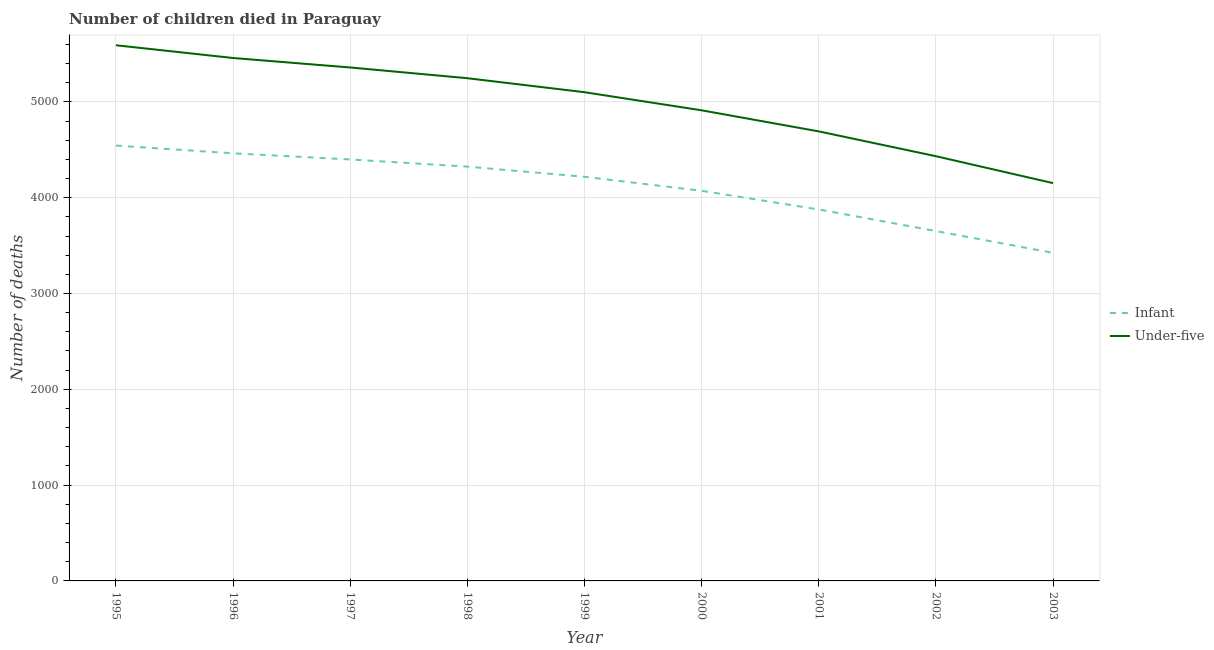How many different coloured lines are there?
Offer a terse response. 2. Does the line corresponding to number of infant deaths intersect with the line corresponding to number of under-five deaths?
Give a very brief answer. No. Is the number of lines equal to the number of legend labels?
Your answer should be compact. Yes. What is the number of infant deaths in 1996?
Provide a short and direct response. 4463. Across all years, what is the maximum number of infant deaths?
Ensure brevity in your answer.  4544. Across all years, what is the minimum number of under-five deaths?
Provide a succinct answer. 4152. In which year was the number of infant deaths minimum?
Provide a succinct answer. 2003. What is the total number of under-five deaths in the graph?
Ensure brevity in your answer.  4.49e+04. What is the difference between the number of under-five deaths in 2000 and that in 2002?
Provide a short and direct response. 479. What is the difference between the number of under-five deaths in 1998 and the number of infant deaths in 1996?
Your response must be concise. 784. What is the average number of infant deaths per year?
Ensure brevity in your answer.  4108.11. In the year 1997, what is the difference between the number of infant deaths and number of under-five deaths?
Offer a terse response. -960. What is the ratio of the number of under-five deaths in 2001 to that in 2003?
Give a very brief answer. 1.13. What is the difference between the highest and the second highest number of infant deaths?
Give a very brief answer. 81. What is the difference between the highest and the lowest number of infant deaths?
Provide a succinct answer. 1120. In how many years, is the number of infant deaths greater than the average number of infant deaths taken over all years?
Your answer should be very brief. 5. Does the number of under-five deaths monotonically increase over the years?
Your answer should be compact. No. How many lines are there?
Provide a succinct answer. 2. How many years are there in the graph?
Offer a terse response. 9. What is the difference between two consecutive major ticks on the Y-axis?
Your answer should be compact. 1000. Does the graph contain any zero values?
Your answer should be compact. No. What is the title of the graph?
Provide a succinct answer. Number of children died in Paraguay. What is the label or title of the Y-axis?
Offer a very short reply. Number of deaths. What is the Number of deaths of Infant in 1995?
Provide a short and direct response. 4544. What is the Number of deaths in Under-five in 1995?
Provide a short and direct response. 5591. What is the Number of deaths in Infant in 1996?
Provide a short and direct response. 4463. What is the Number of deaths of Under-five in 1996?
Provide a succinct answer. 5458. What is the Number of deaths in Infant in 1997?
Provide a succinct answer. 4399. What is the Number of deaths of Under-five in 1997?
Make the answer very short. 5359. What is the Number of deaths of Infant in 1998?
Make the answer very short. 4324. What is the Number of deaths in Under-five in 1998?
Provide a short and direct response. 5247. What is the Number of deaths of Infant in 1999?
Offer a terse response. 4218. What is the Number of deaths in Under-five in 1999?
Your answer should be very brief. 5101. What is the Number of deaths in Infant in 2000?
Make the answer very short. 4072. What is the Number of deaths in Under-five in 2000?
Make the answer very short. 4912. What is the Number of deaths of Infant in 2001?
Offer a very short reply. 3877. What is the Number of deaths of Under-five in 2001?
Your answer should be very brief. 4692. What is the Number of deaths of Infant in 2002?
Make the answer very short. 3652. What is the Number of deaths in Under-five in 2002?
Your answer should be very brief. 4433. What is the Number of deaths of Infant in 2003?
Your answer should be very brief. 3424. What is the Number of deaths in Under-five in 2003?
Your response must be concise. 4152. Across all years, what is the maximum Number of deaths in Infant?
Offer a terse response. 4544. Across all years, what is the maximum Number of deaths in Under-five?
Keep it short and to the point. 5591. Across all years, what is the minimum Number of deaths in Infant?
Make the answer very short. 3424. Across all years, what is the minimum Number of deaths of Under-five?
Ensure brevity in your answer.  4152. What is the total Number of deaths in Infant in the graph?
Provide a short and direct response. 3.70e+04. What is the total Number of deaths of Under-five in the graph?
Give a very brief answer. 4.49e+04. What is the difference between the Number of deaths in Under-five in 1995 and that in 1996?
Provide a short and direct response. 133. What is the difference between the Number of deaths in Infant in 1995 and that in 1997?
Provide a succinct answer. 145. What is the difference between the Number of deaths in Under-five in 1995 and that in 1997?
Make the answer very short. 232. What is the difference between the Number of deaths in Infant in 1995 and that in 1998?
Offer a terse response. 220. What is the difference between the Number of deaths in Under-five in 1995 and that in 1998?
Offer a terse response. 344. What is the difference between the Number of deaths of Infant in 1995 and that in 1999?
Your response must be concise. 326. What is the difference between the Number of deaths of Under-five in 1995 and that in 1999?
Ensure brevity in your answer.  490. What is the difference between the Number of deaths of Infant in 1995 and that in 2000?
Offer a terse response. 472. What is the difference between the Number of deaths in Under-five in 1995 and that in 2000?
Make the answer very short. 679. What is the difference between the Number of deaths of Infant in 1995 and that in 2001?
Your answer should be compact. 667. What is the difference between the Number of deaths of Under-five in 1995 and that in 2001?
Offer a terse response. 899. What is the difference between the Number of deaths in Infant in 1995 and that in 2002?
Ensure brevity in your answer.  892. What is the difference between the Number of deaths of Under-five in 1995 and that in 2002?
Your response must be concise. 1158. What is the difference between the Number of deaths of Infant in 1995 and that in 2003?
Ensure brevity in your answer.  1120. What is the difference between the Number of deaths in Under-five in 1995 and that in 2003?
Your answer should be compact. 1439. What is the difference between the Number of deaths in Under-five in 1996 and that in 1997?
Make the answer very short. 99. What is the difference between the Number of deaths of Infant in 1996 and that in 1998?
Ensure brevity in your answer.  139. What is the difference between the Number of deaths in Under-five in 1996 and that in 1998?
Keep it short and to the point. 211. What is the difference between the Number of deaths of Infant in 1996 and that in 1999?
Ensure brevity in your answer.  245. What is the difference between the Number of deaths of Under-five in 1996 and that in 1999?
Offer a terse response. 357. What is the difference between the Number of deaths of Infant in 1996 and that in 2000?
Offer a terse response. 391. What is the difference between the Number of deaths in Under-five in 1996 and that in 2000?
Give a very brief answer. 546. What is the difference between the Number of deaths of Infant in 1996 and that in 2001?
Keep it short and to the point. 586. What is the difference between the Number of deaths of Under-five in 1996 and that in 2001?
Provide a succinct answer. 766. What is the difference between the Number of deaths in Infant in 1996 and that in 2002?
Offer a very short reply. 811. What is the difference between the Number of deaths in Under-five in 1996 and that in 2002?
Make the answer very short. 1025. What is the difference between the Number of deaths in Infant in 1996 and that in 2003?
Keep it short and to the point. 1039. What is the difference between the Number of deaths of Under-five in 1996 and that in 2003?
Offer a very short reply. 1306. What is the difference between the Number of deaths of Infant in 1997 and that in 1998?
Keep it short and to the point. 75. What is the difference between the Number of deaths in Under-five in 1997 and that in 1998?
Provide a short and direct response. 112. What is the difference between the Number of deaths of Infant in 1997 and that in 1999?
Your answer should be very brief. 181. What is the difference between the Number of deaths of Under-five in 1997 and that in 1999?
Your answer should be compact. 258. What is the difference between the Number of deaths of Infant in 1997 and that in 2000?
Offer a very short reply. 327. What is the difference between the Number of deaths of Under-five in 1997 and that in 2000?
Your answer should be very brief. 447. What is the difference between the Number of deaths of Infant in 1997 and that in 2001?
Your answer should be very brief. 522. What is the difference between the Number of deaths of Under-five in 1997 and that in 2001?
Keep it short and to the point. 667. What is the difference between the Number of deaths of Infant in 1997 and that in 2002?
Make the answer very short. 747. What is the difference between the Number of deaths in Under-five in 1997 and that in 2002?
Your response must be concise. 926. What is the difference between the Number of deaths of Infant in 1997 and that in 2003?
Provide a short and direct response. 975. What is the difference between the Number of deaths in Under-five in 1997 and that in 2003?
Your answer should be compact. 1207. What is the difference between the Number of deaths of Infant in 1998 and that in 1999?
Ensure brevity in your answer.  106. What is the difference between the Number of deaths in Under-five in 1998 and that in 1999?
Keep it short and to the point. 146. What is the difference between the Number of deaths in Infant in 1998 and that in 2000?
Provide a succinct answer. 252. What is the difference between the Number of deaths in Under-five in 1998 and that in 2000?
Keep it short and to the point. 335. What is the difference between the Number of deaths of Infant in 1998 and that in 2001?
Ensure brevity in your answer.  447. What is the difference between the Number of deaths in Under-five in 1998 and that in 2001?
Your answer should be compact. 555. What is the difference between the Number of deaths in Infant in 1998 and that in 2002?
Provide a short and direct response. 672. What is the difference between the Number of deaths in Under-five in 1998 and that in 2002?
Offer a terse response. 814. What is the difference between the Number of deaths of Infant in 1998 and that in 2003?
Your response must be concise. 900. What is the difference between the Number of deaths of Under-five in 1998 and that in 2003?
Provide a short and direct response. 1095. What is the difference between the Number of deaths in Infant in 1999 and that in 2000?
Your answer should be very brief. 146. What is the difference between the Number of deaths of Under-five in 1999 and that in 2000?
Your answer should be compact. 189. What is the difference between the Number of deaths in Infant in 1999 and that in 2001?
Your answer should be compact. 341. What is the difference between the Number of deaths of Under-five in 1999 and that in 2001?
Provide a short and direct response. 409. What is the difference between the Number of deaths in Infant in 1999 and that in 2002?
Your answer should be compact. 566. What is the difference between the Number of deaths of Under-five in 1999 and that in 2002?
Ensure brevity in your answer.  668. What is the difference between the Number of deaths of Infant in 1999 and that in 2003?
Make the answer very short. 794. What is the difference between the Number of deaths of Under-five in 1999 and that in 2003?
Your response must be concise. 949. What is the difference between the Number of deaths in Infant in 2000 and that in 2001?
Give a very brief answer. 195. What is the difference between the Number of deaths of Under-five in 2000 and that in 2001?
Provide a short and direct response. 220. What is the difference between the Number of deaths in Infant in 2000 and that in 2002?
Offer a terse response. 420. What is the difference between the Number of deaths in Under-five in 2000 and that in 2002?
Make the answer very short. 479. What is the difference between the Number of deaths in Infant in 2000 and that in 2003?
Offer a very short reply. 648. What is the difference between the Number of deaths in Under-five in 2000 and that in 2003?
Your answer should be very brief. 760. What is the difference between the Number of deaths of Infant in 2001 and that in 2002?
Provide a short and direct response. 225. What is the difference between the Number of deaths in Under-five in 2001 and that in 2002?
Provide a succinct answer. 259. What is the difference between the Number of deaths in Infant in 2001 and that in 2003?
Offer a terse response. 453. What is the difference between the Number of deaths in Under-five in 2001 and that in 2003?
Provide a succinct answer. 540. What is the difference between the Number of deaths of Infant in 2002 and that in 2003?
Provide a short and direct response. 228. What is the difference between the Number of deaths of Under-five in 2002 and that in 2003?
Give a very brief answer. 281. What is the difference between the Number of deaths of Infant in 1995 and the Number of deaths of Under-five in 1996?
Keep it short and to the point. -914. What is the difference between the Number of deaths of Infant in 1995 and the Number of deaths of Under-five in 1997?
Make the answer very short. -815. What is the difference between the Number of deaths of Infant in 1995 and the Number of deaths of Under-five in 1998?
Provide a succinct answer. -703. What is the difference between the Number of deaths of Infant in 1995 and the Number of deaths of Under-five in 1999?
Offer a terse response. -557. What is the difference between the Number of deaths of Infant in 1995 and the Number of deaths of Under-five in 2000?
Your answer should be compact. -368. What is the difference between the Number of deaths of Infant in 1995 and the Number of deaths of Under-five in 2001?
Give a very brief answer. -148. What is the difference between the Number of deaths of Infant in 1995 and the Number of deaths of Under-five in 2002?
Provide a short and direct response. 111. What is the difference between the Number of deaths of Infant in 1995 and the Number of deaths of Under-five in 2003?
Ensure brevity in your answer.  392. What is the difference between the Number of deaths of Infant in 1996 and the Number of deaths of Under-five in 1997?
Your response must be concise. -896. What is the difference between the Number of deaths of Infant in 1996 and the Number of deaths of Under-five in 1998?
Give a very brief answer. -784. What is the difference between the Number of deaths of Infant in 1996 and the Number of deaths of Under-five in 1999?
Offer a very short reply. -638. What is the difference between the Number of deaths in Infant in 1996 and the Number of deaths in Under-five in 2000?
Provide a short and direct response. -449. What is the difference between the Number of deaths of Infant in 1996 and the Number of deaths of Under-five in 2001?
Provide a short and direct response. -229. What is the difference between the Number of deaths in Infant in 1996 and the Number of deaths in Under-five in 2003?
Provide a succinct answer. 311. What is the difference between the Number of deaths in Infant in 1997 and the Number of deaths in Under-five in 1998?
Your answer should be very brief. -848. What is the difference between the Number of deaths in Infant in 1997 and the Number of deaths in Under-five in 1999?
Ensure brevity in your answer.  -702. What is the difference between the Number of deaths in Infant in 1997 and the Number of deaths in Under-five in 2000?
Give a very brief answer. -513. What is the difference between the Number of deaths in Infant in 1997 and the Number of deaths in Under-five in 2001?
Provide a succinct answer. -293. What is the difference between the Number of deaths in Infant in 1997 and the Number of deaths in Under-five in 2002?
Provide a succinct answer. -34. What is the difference between the Number of deaths in Infant in 1997 and the Number of deaths in Under-five in 2003?
Your answer should be very brief. 247. What is the difference between the Number of deaths in Infant in 1998 and the Number of deaths in Under-five in 1999?
Keep it short and to the point. -777. What is the difference between the Number of deaths in Infant in 1998 and the Number of deaths in Under-five in 2000?
Provide a short and direct response. -588. What is the difference between the Number of deaths in Infant in 1998 and the Number of deaths in Under-five in 2001?
Provide a succinct answer. -368. What is the difference between the Number of deaths in Infant in 1998 and the Number of deaths in Under-five in 2002?
Offer a very short reply. -109. What is the difference between the Number of deaths of Infant in 1998 and the Number of deaths of Under-five in 2003?
Your answer should be very brief. 172. What is the difference between the Number of deaths of Infant in 1999 and the Number of deaths of Under-five in 2000?
Provide a succinct answer. -694. What is the difference between the Number of deaths in Infant in 1999 and the Number of deaths in Under-five in 2001?
Provide a short and direct response. -474. What is the difference between the Number of deaths of Infant in 1999 and the Number of deaths of Under-five in 2002?
Keep it short and to the point. -215. What is the difference between the Number of deaths of Infant in 1999 and the Number of deaths of Under-five in 2003?
Keep it short and to the point. 66. What is the difference between the Number of deaths in Infant in 2000 and the Number of deaths in Under-five in 2001?
Offer a terse response. -620. What is the difference between the Number of deaths in Infant in 2000 and the Number of deaths in Under-five in 2002?
Offer a very short reply. -361. What is the difference between the Number of deaths in Infant in 2000 and the Number of deaths in Under-five in 2003?
Ensure brevity in your answer.  -80. What is the difference between the Number of deaths in Infant in 2001 and the Number of deaths in Under-five in 2002?
Make the answer very short. -556. What is the difference between the Number of deaths in Infant in 2001 and the Number of deaths in Under-five in 2003?
Your response must be concise. -275. What is the difference between the Number of deaths in Infant in 2002 and the Number of deaths in Under-five in 2003?
Give a very brief answer. -500. What is the average Number of deaths of Infant per year?
Ensure brevity in your answer.  4108.11. What is the average Number of deaths in Under-five per year?
Ensure brevity in your answer.  4993.89. In the year 1995, what is the difference between the Number of deaths of Infant and Number of deaths of Under-five?
Provide a short and direct response. -1047. In the year 1996, what is the difference between the Number of deaths in Infant and Number of deaths in Under-five?
Provide a short and direct response. -995. In the year 1997, what is the difference between the Number of deaths in Infant and Number of deaths in Under-five?
Keep it short and to the point. -960. In the year 1998, what is the difference between the Number of deaths of Infant and Number of deaths of Under-five?
Keep it short and to the point. -923. In the year 1999, what is the difference between the Number of deaths in Infant and Number of deaths in Under-five?
Provide a succinct answer. -883. In the year 2000, what is the difference between the Number of deaths in Infant and Number of deaths in Under-five?
Make the answer very short. -840. In the year 2001, what is the difference between the Number of deaths of Infant and Number of deaths of Under-five?
Keep it short and to the point. -815. In the year 2002, what is the difference between the Number of deaths of Infant and Number of deaths of Under-five?
Provide a succinct answer. -781. In the year 2003, what is the difference between the Number of deaths of Infant and Number of deaths of Under-five?
Your answer should be very brief. -728. What is the ratio of the Number of deaths in Infant in 1995 to that in 1996?
Your answer should be very brief. 1.02. What is the ratio of the Number of deaths in Under-five in 1995 to that in 1996?
Offer a terse response. 1.02. What is the ratio of the Number of deaths of Infant in 1995 to that in 1997?
Give a very brief answer. 1.03. What is the ratio of the Number of deaths of Under-five in 1995 to that in 1997?
Give a very brief answer. 1.04. What is the ratio of the Number of deaths in Infant in 1995 to that in 1998?
Your answer should be compact. 1.05. What is the ratio of the Number of deaths in Under-five in 1995 to that in 1998?
Your response must be concise. 1.07. What is the ratio of the Number of deaths in Infant in 1995 to that in 1999?
Give a very brief answer. 1.08. What is the ratio of the Number of deaths in Under-five in 1995 to that in 1999?
Offer a very short reply. 1.1. What is the ratio of the Number of deaths in Infant in 1995 to that in 2000?
Provide a short and direct response. 1.12. What is the ratio of the Number of deaths of Under-five in 1995 to that in 2000?
Give a very brief answer. 1.14. What is the ratio of the Number of deaths of Infant in 1995 to that in 2001?
Offer a terse response. 1.17. What is the ratio of the Number of deaths in Under-five in 1995 to that in 2001?
Ensure brevity in your answer.  1.19. What is the ratio of the Number of deaths of Infant in 1995 to that in 2002?
Offer a very short reply. 1.24. What is the ratio of the Number of deaths of Under-five in 1995 to that in 2002?
Offer a terse response. 1.26. What is the ratio of the Number of deaths in Infant in 1995 to that in 2003?
Keep it short and to the point. 1.33. What is the ratio of the Number of deaths in Under-five in 1995 to that in 2003?
Provide a succinct answer. 1.35. What is the ratio of the Number of deaths of Infant in 1996 to that in 1997?
Give a very brief answer. 1.01. What is the ratio of the Number of deaths of Under-five in 1996 to that in 1997?
Offer a very short reply. 1.02. What is the ratio of the Number of deaths in Infant in 1996 to that in 1998?
Your answer should be very brief. 1.03. What is the ratio of the Number of deaths of Under-five in 1996 to that in 1998?
Offer a terse response. 1.04. What is the ratio of the Number of deaths in Infant in 1996 to that in 1999?
Your answer should be compact. 1.06. What is the ratio of the Number of deaths of Under-five in 1996 to that in 1999?
Make the answer very short. 1.07. What is the ratio of the Number of deaths of Infant in 1996 to that in 2000?
Give a very brief answer. 1.1. What is the ratio of the Number of deaths in Under-five in 1996 to that in 2000?
Make the answer very short. 1.11. What is the ratio of the Number of deaths of Infant in 1996 to that in 2001?
Ensure brevity in your answer.  1.15. What is the ratio of the Number of deaths of Under-five in 1996 to that in 2001?
Offer a terse response. 1.16. What is the ratio of the Number of deaths in Infant in 1996 to that in 2002?
Your answer should be compact. 1.22. What is the ratio of the Number of deaths in Under-five in 1996 to that in 2002?
Your response must be concise. 1.23. What is the ratio of the Number of deaths of Infant in 1996 to that in 2003?
Provide a short and direct response. 1.3. What is the ratio of the Number of deaths in Under-five in 1996 to that in 2003?
Give a very brief answer. 1.31. What is the ratio of the Number of deaths in Infant in 1997 to that in 1998?
Your answer should be compact. 1.02. What is the ratio of the Number of deaths of Under-five in 1997 to that in 1998?
Offer a very short reply. 1.02. What is the ratio of the Number of deaths of Infant in 1997 to that in 1999?
Your answer should be very brief. 1.04. What is the ratio of the Number of deaths in Under-five in 1997 to that in 1999?
Provide a short and direct response. 1.05. What is the ratio of the Number of deaths in Infant in 1997 to that in 2000?
Ensure brevity in your answer.  1.08. What is the ratio of the Number of deaths in Under-five in 1997 to that in 2000?
Provide a succinct answer. 1.09. What is the ratio of the Number of deaths in Infant in 1997 to that in 2001?
Offer a very short reply. 1.13. What is the ratio of the Number of deaths in Under-five in 1997 to that in 2001?
Offer a terse response. 1.14. What is the ratio of the Number of deaths of Infant in 1997 to that in 2002?
Your answer should be compact. 1.2. What is the ratio of the Number of deaths in Under-five in 1997 to that in 2002?
Your answer should be compact. 1.21. What is the ratio of the Number of deaths of Infant in 1997 to that in 2003?
Your answer should be very brief. 1.28. What is the ratio of the Number of deaths in Under-five in 1997 to that in 2003?
Keep it short and to the point. 1.29. What is the ratio of the Number of deaths in Infant in 1998 to that in 1999?
Offer a terse response. 1.03. What is the ratio of the Number of deaths of Under-five in 1998 to that in 1999?
Make the answer very short. 1.03. What is the ratio of the Number of deaths in Infant in 1998 to that in 2000?
Provide a succinct answer. 1.06. What is the ratio of the Number of deaths of Under-five in 1998 to that in 2000?
Offer a very short reply. 1.07. What is the ratio of the Number of deaths of Infant in 1998 to that in 2001?
Ensure brevity in your answer.  1.12. What is the ratio of the Number of deaths in Under-five in 1998 to that in 2001?
Keep it short and to the point. 1.12. What is the ratio of the Number of deaths of Infant in 1998 to that in 2002?
Ensure brevity in your answer.  1.18. What is the ratio of the Number of deaths in Under-five in 1998 to that in 2002?
Your answer should be very brief. 1.18. What is the ratio of the Number of deaths of Infant in 1998 to that in 2003?
Keep it short and to the point. 1.26. What is the ratio of the Number of deaths in Under-five in 1998 to that in 2003?
Make the answer very short. 1.26. What is the ratio of the Number of deaths of Infant in 1999 to that in 2000?
Give a very brief answer. 1.04. What is the ratio of the Number of deaths of Under-five in 1999 to that in 2000?
Provide a short and direct response. 1.04. What is the ratio of the Number of deaths in Infant in 1999 to that in 2001?
Your answer should be compact. 1.09. What is the ratio of the Number of deaths of Under-five in 1999 to that in 2001?
Offer a very short reply. 1.09. What is the ratio of the Number of deaths in Infant in 1999 to that in 2002?
Provide a short and direct response. 1.16. What is the ratio of the Number of deaths of Under-five in 1999 to that in 2002?
Offer a terse response. 1.15. What is the ratio of the Number of deaths in Infant in 1999 to that in 2003?
Ensure brevity in your answer.  1.23. What is the ratio of the Number of deaths of Under-five in 1999 to that in 2003?
Your answer should be very brief. 1.23. What is the ratio of the Number of deaths of Infant in 2000 to that in 2001?
Offer a very short reply. 1.05. What is the ratio of the Number of deaths of Under-five in 2000 to that in 2001?
Offer a terse response. 1.05. What is the ratio of the Number of deaths in Infant in 2000 to that in 2002?
Keep it short and to the point. 1.11. What is the ratio of the Number of deaths of Under-five in 2000 to that in 2002?
Ensure brevity in your answer.  1.11. What is the ratio of the Number of deaths of Infant in 2000 to that in 2003?
Offer a terse response. 1.19. What is the ratio of the Number of deaths in Under-five in 2000 to that in 2003?
Keep it short and to the point. 1.18. What is the ratio of the Number of deaths in Infant in 2001 to that in 2002?
Ensure brevity in your answer.  1.06. What is the ratio of the Number of deaths in Under-five in 2001 to that in 2002?
Make the answer very short. 1.06. What is the ratio of the Number of deaths in Infant in 2001 to that in 2003?
Your response must be concise. 1.13. What is the ratio of the Number of deaths in Under-five in 2001 to that in 2003?
Your response must be concise. 1.13. What is the ratio of the Number of deaths in Infant in 2002 to that in 2003?
Provide a succinct answer. 1.07. What is the ratio of the Number of deaths in Under-five in 2002 to that in 2003?
Keep it short and to the point. 1.07. What is the difference between the highest and the second highest Number of deaths in Under-five?
Provide a succinct answer. 133. What is the difference between the highest and the lowest Number of deaths of Infant?
Offer a terse response. 1120. What is the difference between the highest and the lowest Number of deaths in Under-five?
Keep it short and to the point. 1439. 